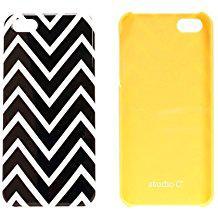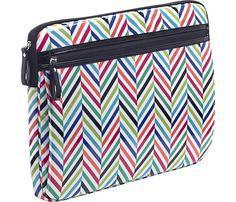The first image is the image on the left, the second image is the image on the right. Analyze the images presented: Is the assertion "A school supply has a print of a cartoon face in one of the images." valid? Answer yes or no. No. The first image is the image on the left, the second image is the image on the right. Given the left and right images, does the statement "A zipper case has a black-and-white zig zag pattern on the bottom and a yellowish band across the top." hold true? Answer yes or no. No. 